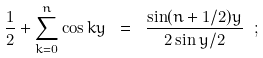Convert formula to latex. <formula><loc_0><loc_0><loc_500><loc_500>\frac { 1 } { 2 } + \sum _ { k = 0 } ^ { n } \cos k y \ = \ \frac { \sin ( n + 1 / 2 ) y } { 2 \sin y / 2 } \ ;</formula> 